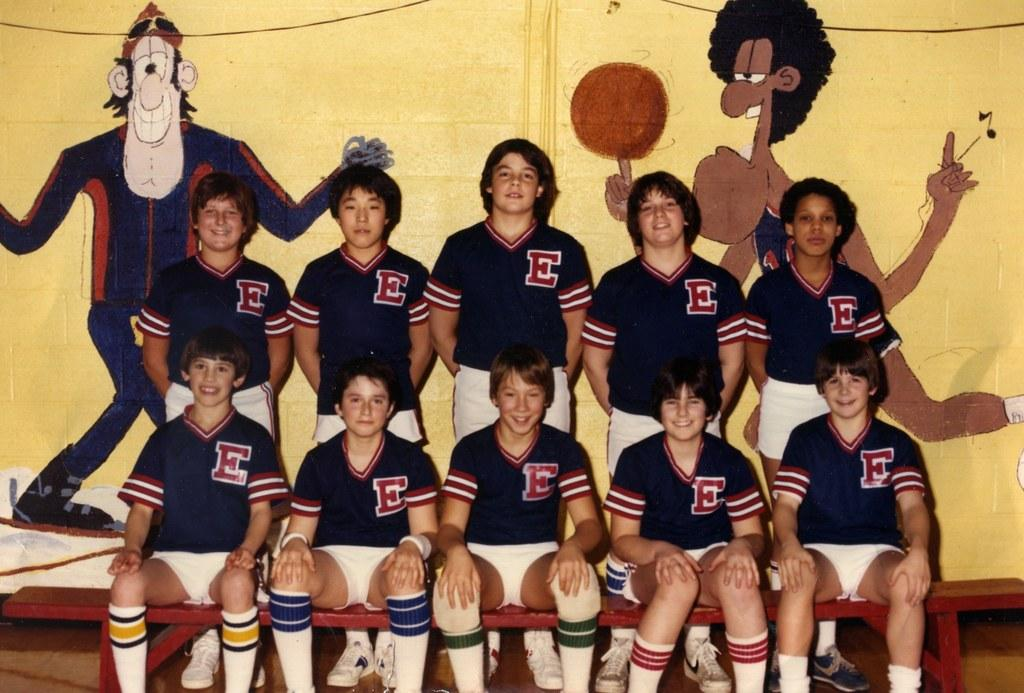<image>
Give a short and clear explanation of the subsequent image. A group of boys are sitting on a bleacher and all of their uniforms have an E on them. 